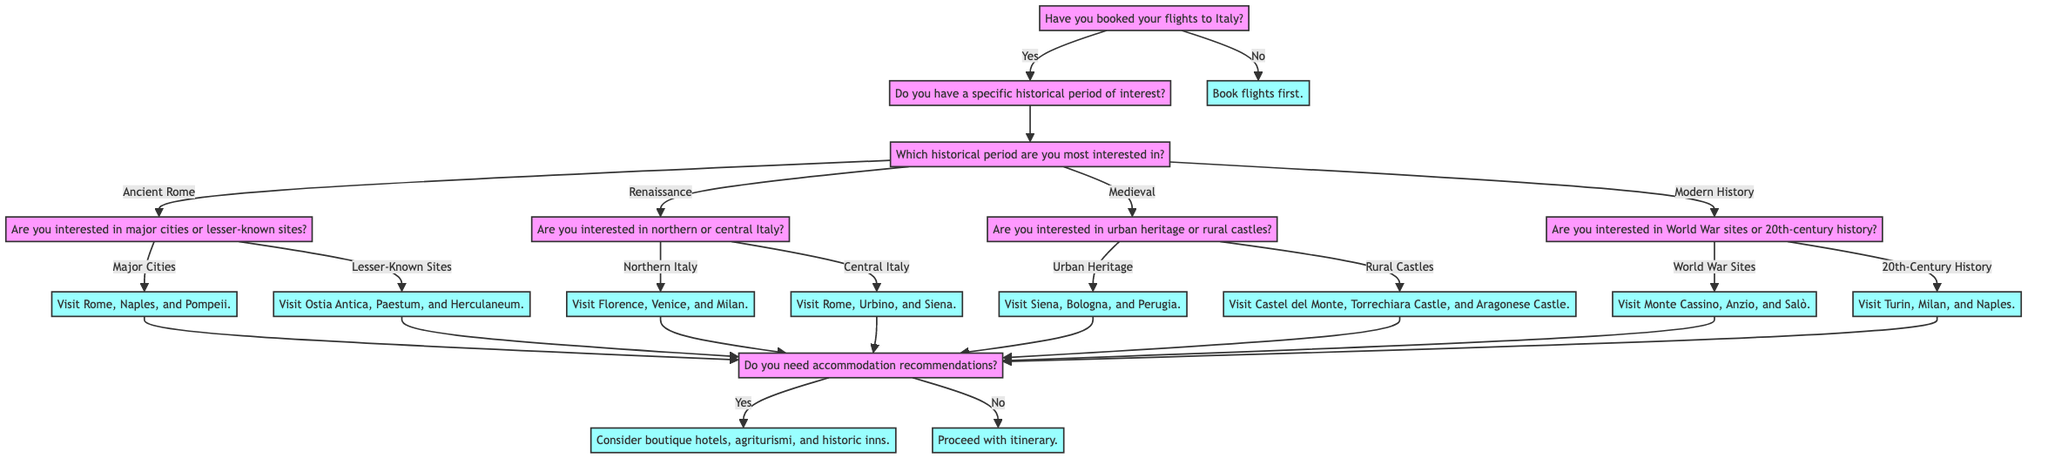What is the first question in the diagram? The first question in the diagram is "Have you booked your flights to Italy?" which is asked to initiate the decision-making process for planning the trip.
Answer: Have you booked your flights to Italy? What is the outcome if the answer is "No" to the first question? If the answer to "Have you booked your flights to Italy?" is "No," the diagram states the outcome is to "Book flights first," indicating that booking flights is a prerequisite.
Answer: Book flights first How many historical periods are listed in the decision tree? The diagram lists four historical periods: Ancient Rome, Renaissance, Medieval, and Modern History. Therefore, counting these, there are four distinct categories for the visitors' interest.
Answer: Four What happens if someone is interested in "Lesser-Known Sites" under "Ancient Rome"? If a traveler indicates they are interested in "Lesser-Known Sites" under "Ancient Rome," the outcome will direct them to "Visit Ostia Antica, Paestum, and Herculaneum," which focuses on these specific sites.
Answer: Visit Ostia Antica, Paestum, and Herculaneum What is the final question in the diagram after visiting sites? The final question in the decision tree concerns accommodation recommendations: "Do you need accommodation recommendations?" which helps finalize the trip planning.
Answer: Do you need accommodation recommendations? If a traveler wants to explore "20th-Century History," what destinations does the decision tree suggest? The decision tree states that if a person is interested in "20th-Century History," they should "Visit Turin, Milan, and Naples," indicating these are key locations of interest for that topic.
Answer: Visit Turin, Milan, and Naples What is the outcome if a person is interested in "Urban Heritage" during the "Medieval" historical period? If someone shows interest in "Urban Heritage" under "Medieval," the decision tree indicates they should "Visit Siena, Bologna, and Perugia," which are notable cities from that era.
Answer: Visit Siena, Bologna, and Perugia What does the diagram recommend if a traveler is interested in "World War Sites"? If a traveler is interested in "World War Sites" under the "Modern History" category, the recommendation is to "Visit Monte Cassino, Anzio, and Salò," which are prominent sites of significance related to the world wars.
Answer: Visit Monte Cassino, Anzio, and Salò 